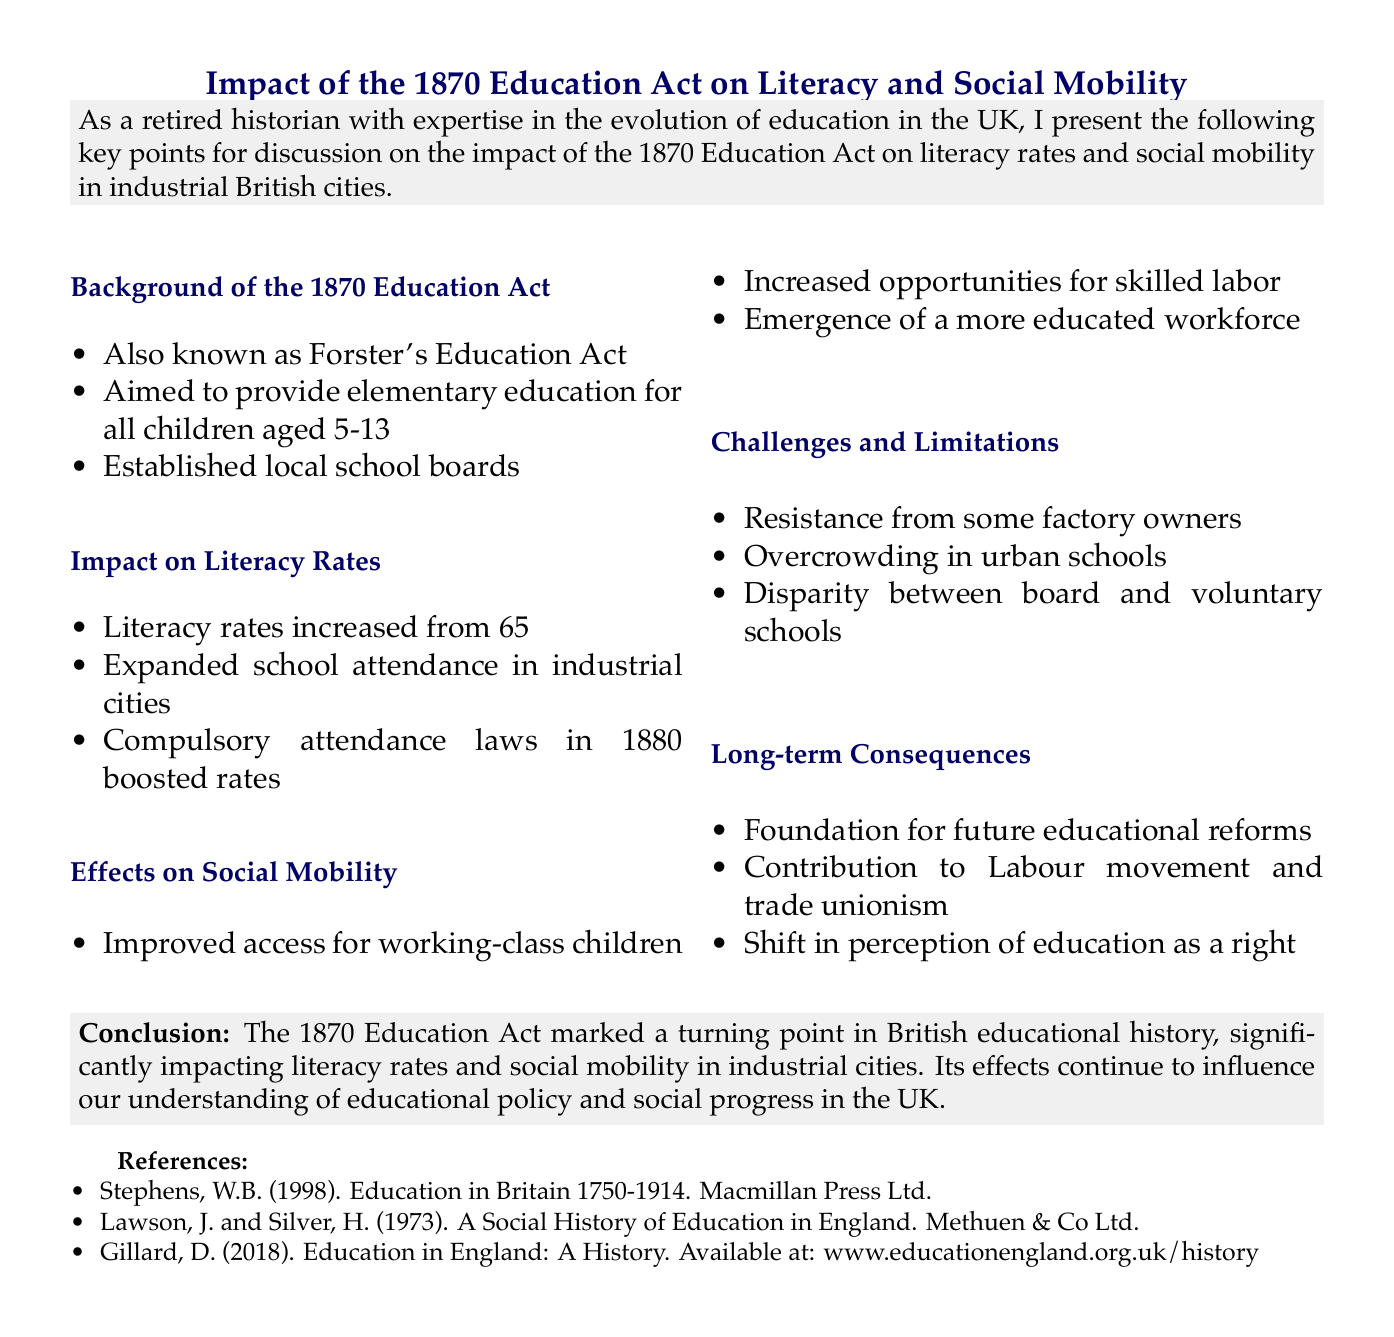What is the full title of the 1870 Education Act? The 1870 Education Act is also known as Forster's Education Act, named after William Edward Forster.
Answer: Forster's Education Act What was the literacy rate in 1900? The document states that literacy rates increased to 95% by 1900.
Answer: 95% What year were compulsory attendance laws introduced? The introduction of compulsory attendance laws occurred in 1880, according to the document.
Answer: 1880 Which industrial city is mentioned as having expanded school attendance? The key points mention industrial cities like Manchester, Birmingham, and Leeds that experienced expanded school attendance.
Answer: Manchester What was one challenge faced by urban schools after the 1870 Education Act? One challenge noted was overcrowding in urban schools, particularly in London's East End.
Answer: Overcrowding How did the 1870 Education Act affect social mobility? The Act improved access to education for working-class children, which increased opportunities for skilled labor and a more educated workforce.
Answer: Improved access to education What was the long-term consequence of the 1870 Education Act? The Act laid the foundation for future educational reforms, including the 1902 Education Act.
Answer: Future educational reforms What percentage was the literacy rate around 1870? According to the document, literacy rates were approximately 65% in 1870.
Answer: 65% 